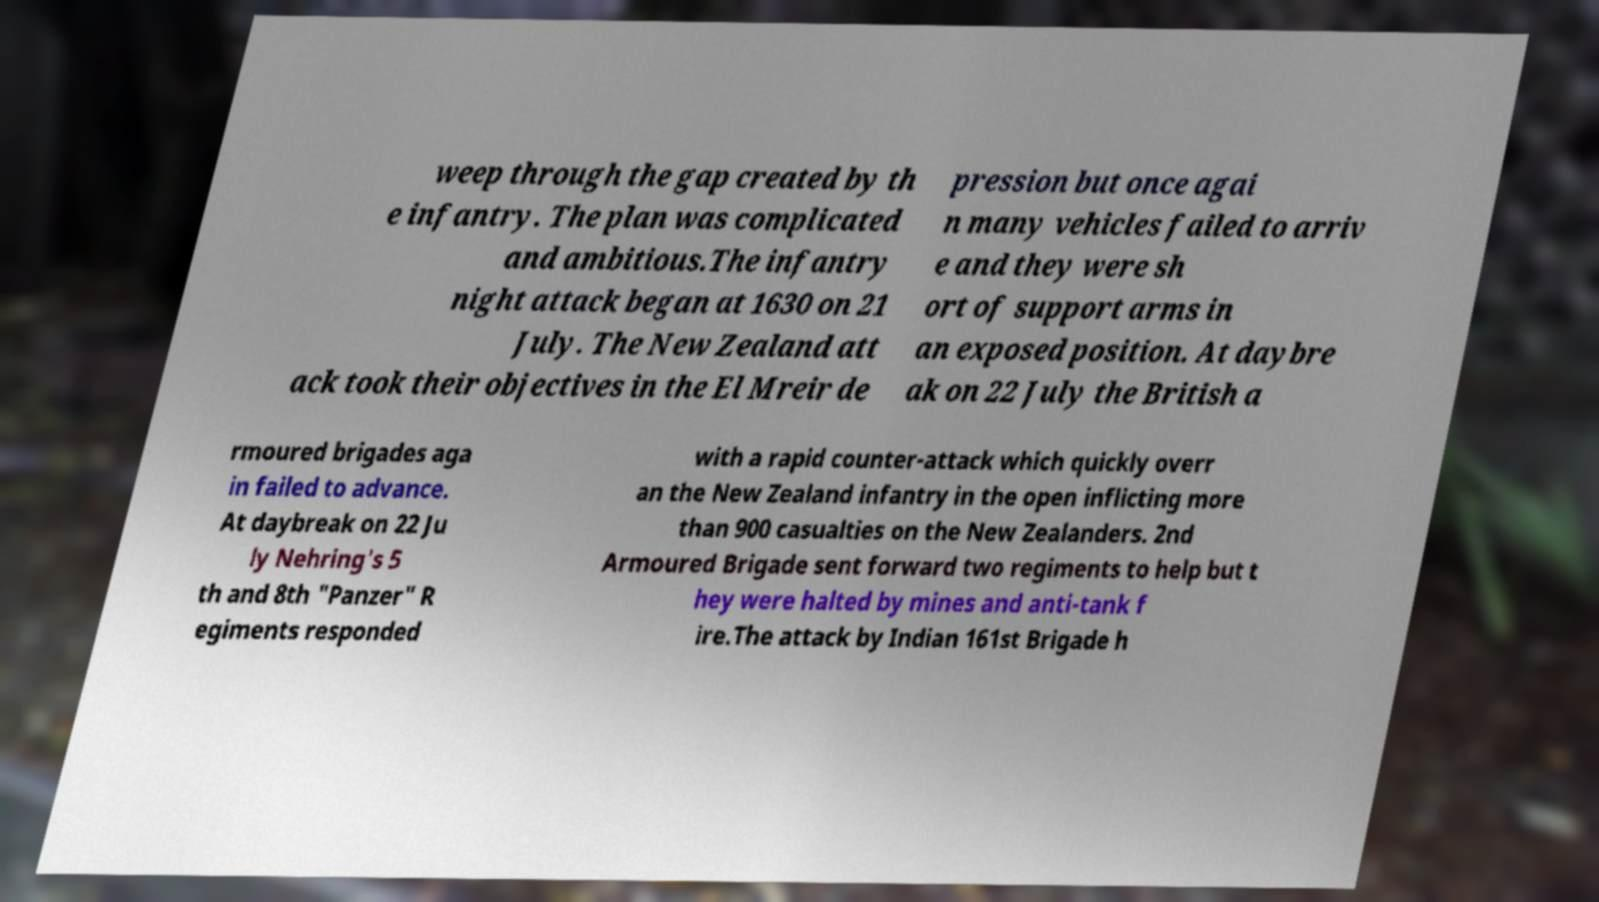I need the written content from this picture converted into text. Can you do that? weep through the gap created by th e infantry. The plan was complicated and ambitious.The infantry night attack began at 1630 on 21 July. The New Zealand att ack took their objectives in the El Mreir de pression but once agai n many vehicles failed to arriv e and they were sh ort of support arms in an exposed position. At daybre ak on 22 July the British a rmoured brigades aga in failed to advance. At daybreak on 22 Ju ly Nehring's 5 th and 8th "Panzer" R egiments responded with a rapid counter-attack which quickly overr an the New Zealand infantry in the open inflicting more than 900 casualties on the New Zealanders. 2nd Armoured Brigade sent forward two regiments to help but t hey were halted by mines and anti-tank f ire.The attack by Indian 161st Brigade h 